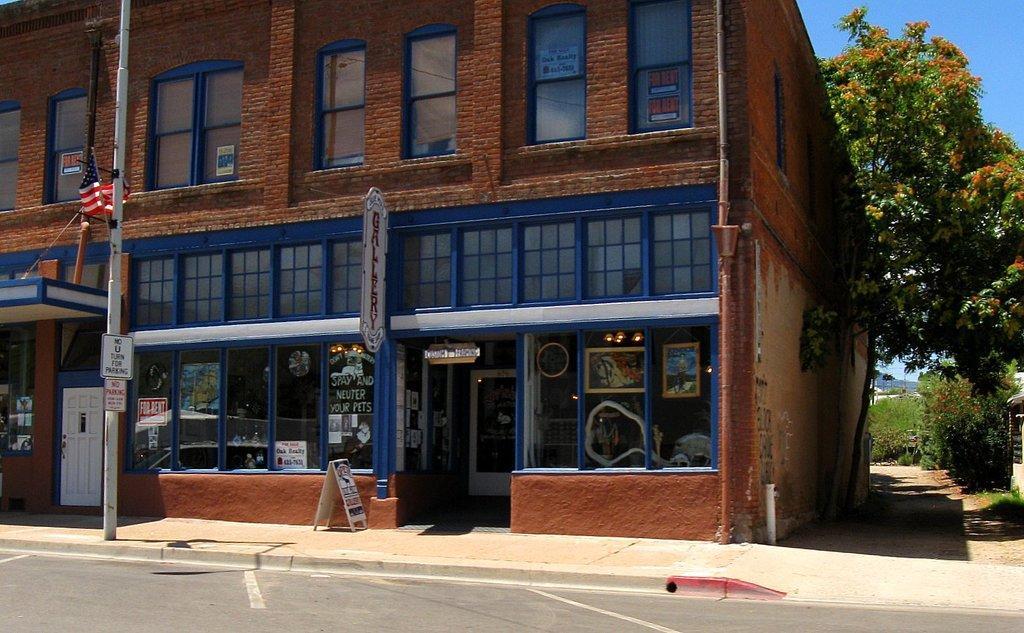Could you give a brief overview of what you see in this image? In this image I can see few stalls, lights and I can also see the flag, pole and the building is in brown color and I can also see few glass windows, trees in green color and the sky is in blue color. 